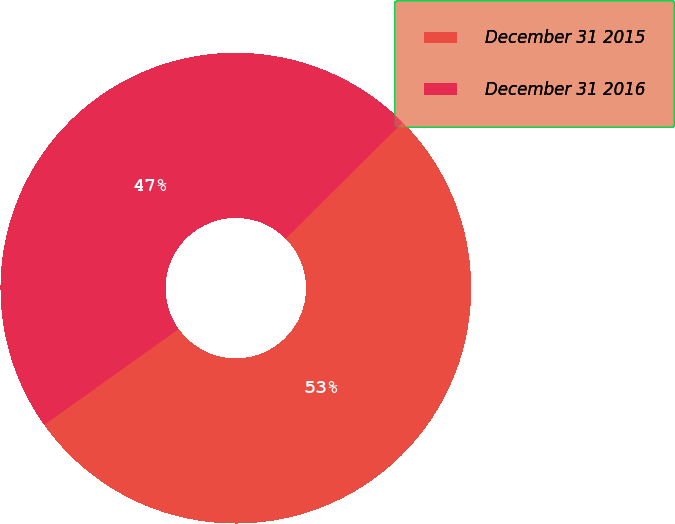Convert chart to OTSL. <chart><loc_0><loc_0><loc_500><loc_500><pie_chart><fcel>December 31 2015<fcel>December 31 2016<nl><fcel>52.59%<fcel>47.41%<nl></chart> 